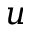<formula> <loc_0><loc_0><loc_500><loc_500>u</formula> 